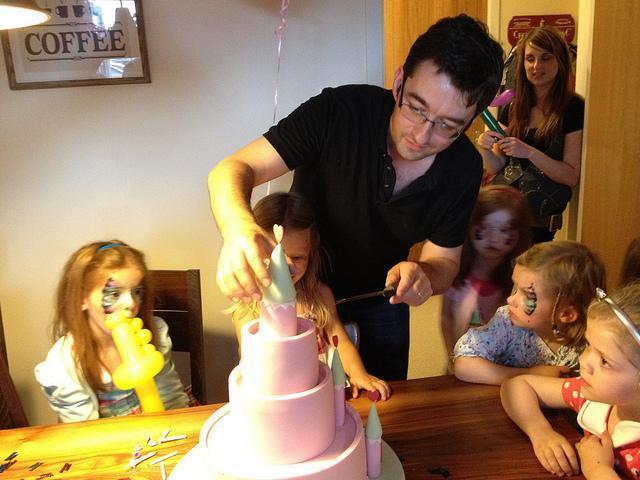How many men are in this picture?
Give a very brief answer. 1. How many kids in the picture?
Give a very brief answer. 5. How many people can be seen?
Give a very brief answer. 7. How many chairs are there?
Give a very brief answer. 2. How many red color pizza on the bowl?
Give a very brief answer. 0. 